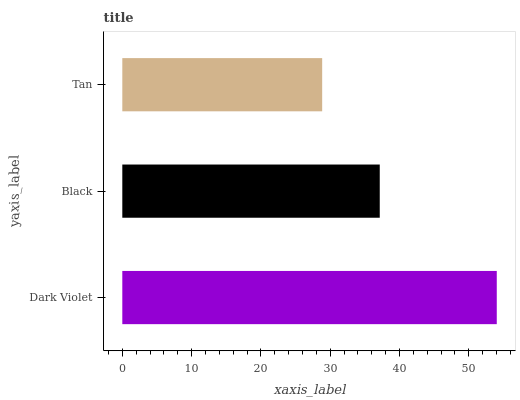Is Tan the minimum?
Answer yes or no. Yes. Is Dark Violet the maximum?
Answer yes or no. Yes. Is Black the minimum?
Answer yes or no. No. Is Black the maximum?
Answer yes or no. No. Is Dark Violet greater than Black?
Answer yes or no. Yes. Is Black less than Dark Violet?
Answer yes or no. Yes. Is Black greater than Dark Violet?
Answer yes or no. No. Is Dark Violet less than Black?
Answer yes or no. No. Is Black the high median?
Answer yes or no. Yes. Is Black the low median?
Answer yes or no. Yes. Is Tan the high median?
Answer yes or no. No. Is Dark Violet the low median?
Answer yes or no. No. 